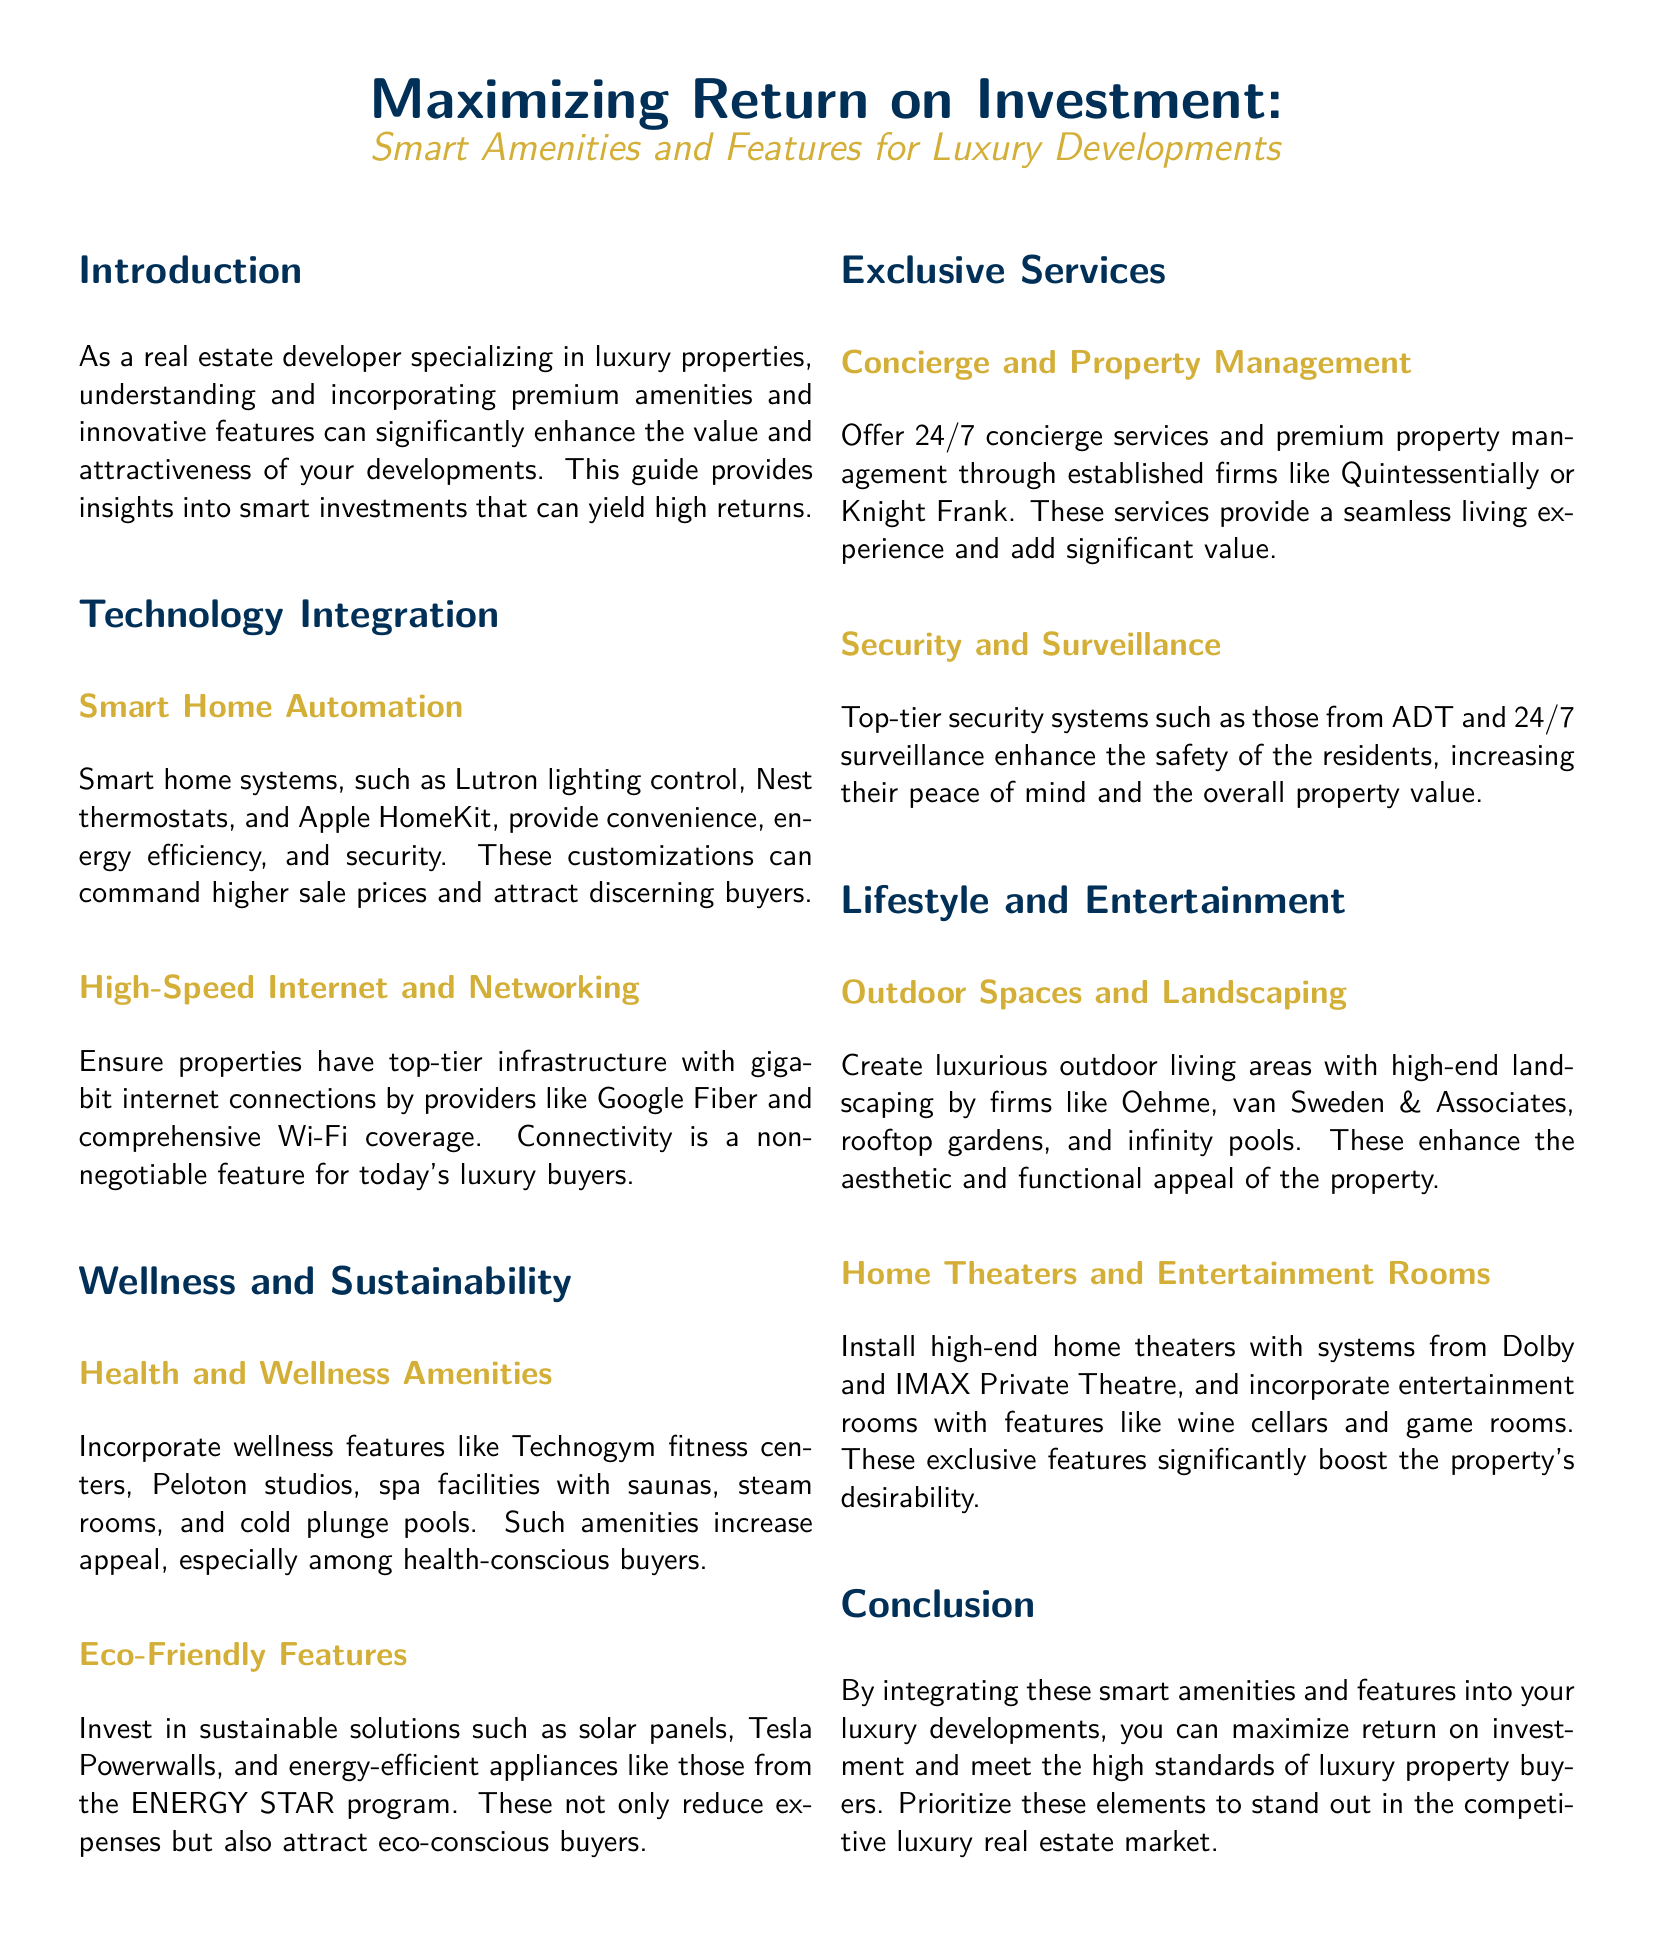What is the title of the document? The title of the document is prominently stated at the top as part of the heading.
Answer: Maximizing Return on Investment: Smart Amenities and Features for Luxury Developments What color is used for the section titles? The section titles in the document are formatted with a specific color to enhance visibility and aesthetics.
Answer: luxuryblue What type of systems are mentioned under Smart Home Automation? The document lists examples of systems under this category to highlight smart home features.
Answer: Lutron lighting control, Nest thermostats, Apple HomeKit What kind of fitness amenities are included as health features? The document specifies various fitness-related facilities that cater to health-focused buyers.
Answer: Technogym fitness centers, Peloton studios Which firm is mentioned for 24/7 concierge services? The document refers to a specific company known for premium property management services.
Answer: Quintessentially Which eco-friendly feature can reduce expenses? The document identifies eco-friendly amenities that contribute to cost savings for residents.
Answer: Solar panels What luxury outdoor feature enhances aesthetic appeal? The document highlights exclusive outdoor features that improve the property's visual and functional aspects.
Answer: Rooftop gardens How do high-speed internet connections benefit luxury properties? The reasoning is based on the importance of connectivity as a selling point for contemporary buyers.
Answer: Attract discerning buyers What is the benefit of integrating smart amenities in luxury developments? The conclusion of the document states the primary advantage of these integrations for developers.
Answer: Maximize return on investment 